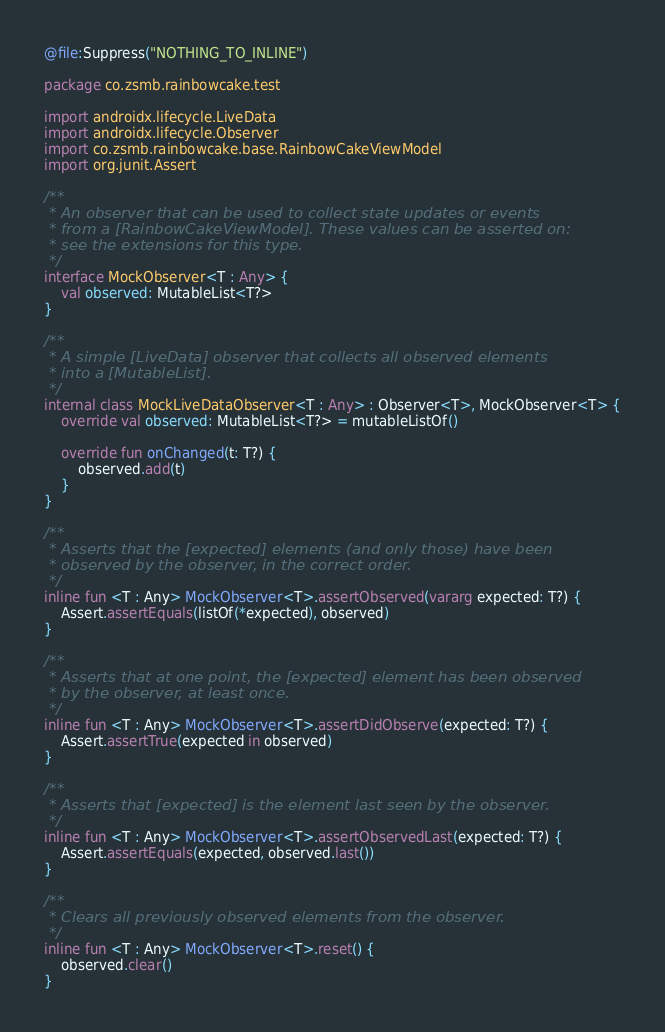Convert code to text. <code><loc_0><loc_0><loc_500><loc_500><_Kotlin_>@file:Suppress("NOTHING_TO_INLINE")

package co.zsmb.rainbowcake.test

import androidx.lifecycle.LiveData
import androidx.lifecycle.Observer
import co.zsmb.rainbowcake.base.RainbowCakeViewModel
import org.junit.Assert

/**
 * An observer that can be used to collect state updates or events
 * from a [RainbowCakeViewModel]. These values can be asserted on:
 * see the extensions for this type.
 */
interface MockObserver<T : Any> {
    val observed: MutableList<T?>
}

/**
 * A simple [LiveData] observer that collects all observed elements
 * into a [MutableList].
 */
internal class MockLiveDataObserver<T : Any> : Observer<T>, MockObserver<T> {
    override val observed: MutableList<T?> = mutableListOf()

    override fun onChanged(t: T?) {
        observed.add(t)
    }
}

/**
 * Asserts that the [expected] elements (and only those) have been
 * observed by the observer, in the correct order.
 */
inline fun <T : Any> MockObserver<T>.assertObserved(vararg expected: T?) {
    Assert.assertEquals(listOf(*expected), observed)
}

/**
 * Asserts that at one point, the [expected] element has been observed
 * by the observer, at least once.
 */
inline fun <T : Any> MockObserver<T>.assertDidObserve(expected: T?) {
    Assert.assertTrue(expected in observed)
}

/**
 * Asserts that [expected] is the element last seen by the observer.
 */
inline fun <T : Any> MockObserver<T>.assertObservedLast(expected: T?) {
    Assert.assertEquals(expected, observed.last())
}

/**
 * Clears all previously observed elements from the observer.
 */
inline fun <T : Any> MockObserver<T>.reset() {
    observed.clear()
}
</code> 